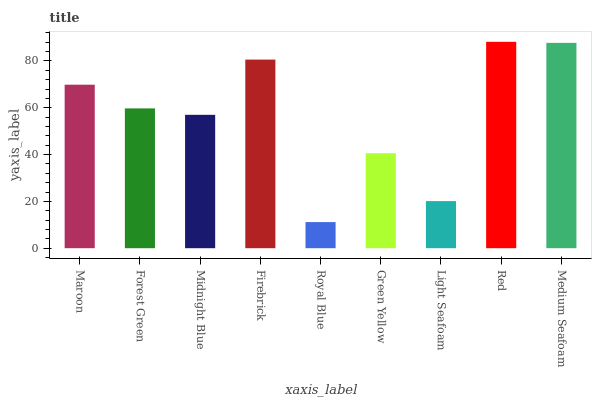Is Royal Blue the minimum?
Answer yes or no. Yes. Is Red the maximum?
Answer yes or no. Yes. Is Forest Green the minimum?
Answer yes or no. No. Is Forest Green the maximum?
Answer yes or no. No. Is Maroon greater than Forest Green?
Answer yes or no. Yes. Is Forest Green less than Maroon?
Answer yes or no. Yes. Is Forest Green greater than Maroon?
Answer yes or no. No. Is Maroon less than Forest Green?
Answer yes or no. No. Is Forest Green the high median?
Answer yes or no. Yes. Is Forest Green the low median?
Answer yes or no. Yes. Is Royal Blue the high median?
Answer yes or no. No. Is Royal Blue the low median?
Answer yes or no. No. 